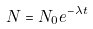Convert formula to latex. <formula><loc_0><loc_0><loc_500><loc_500>N = N _ { 0 } e ^ { - \lambda t }</formula> 